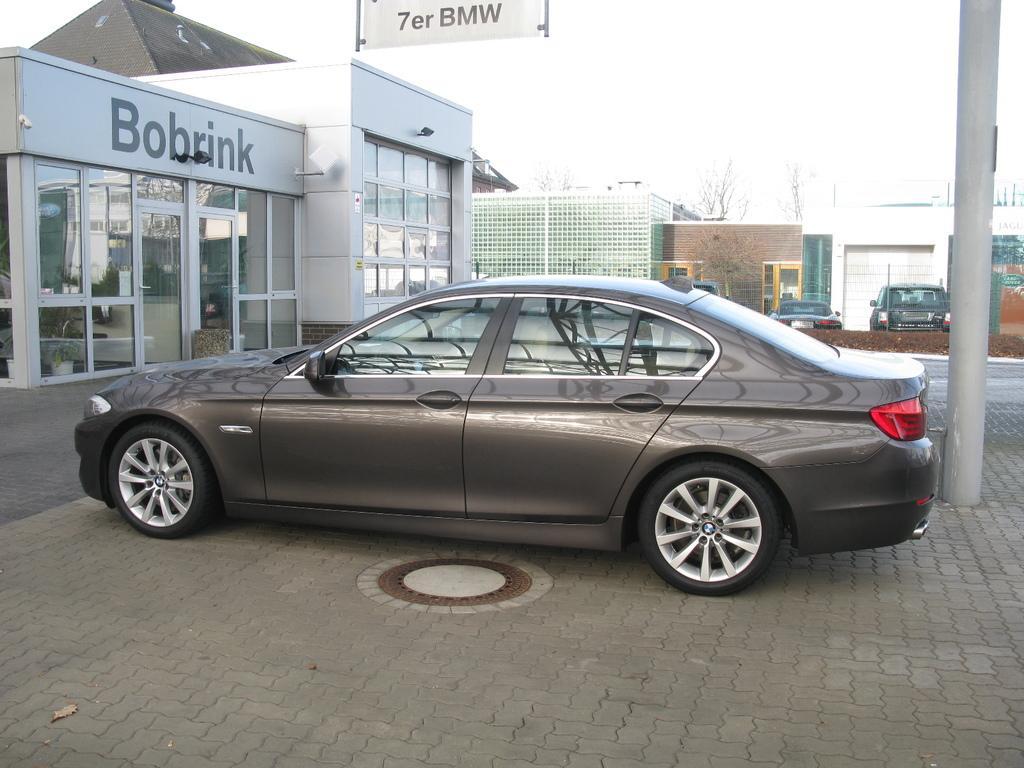Describe this image in one or two sentences. In the center of the picture there is a car. In the background there are buildings and trees and cars. On the right there is a pole. 